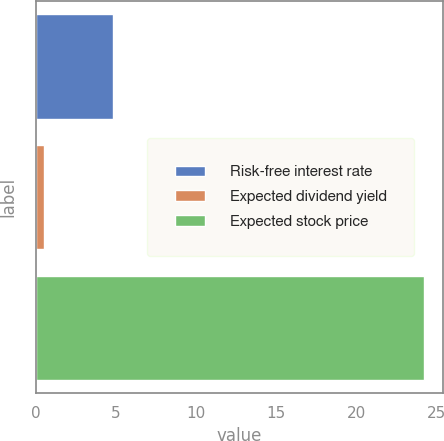<chart> <loc_0><loc_0><loc_500><loc_500><bar_chart><fcel>Risk-free interest rate<fcel>Expected dividend yield<fcel>Expected stock price<nl><fcel>4.8<fcel>0.5<fcel>24.2<nl></chart> 